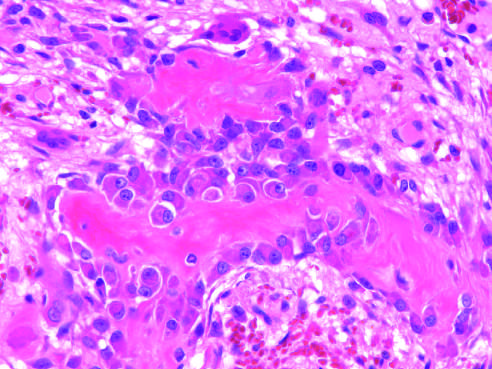what do the surrounding spindle cells represent?
Answer the question using a single word or phrase. The osteoprogenitor cells 